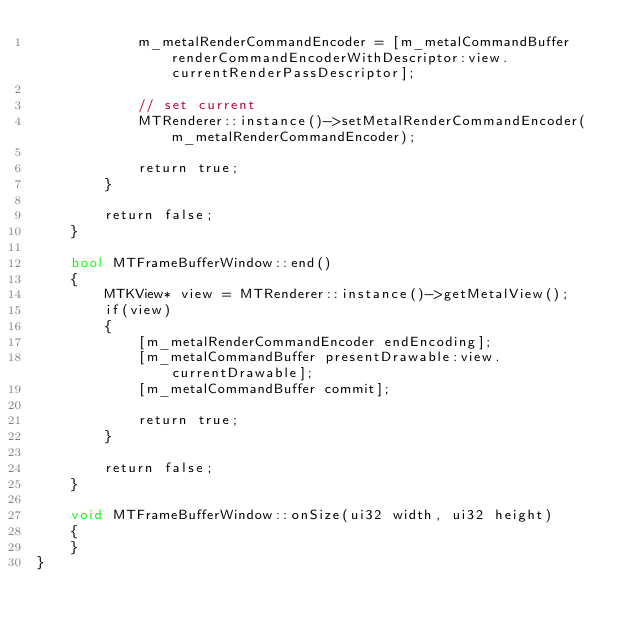<code> <loc_0><loc_0><loc_500><loc_500><_ObjectiveC_>            m_metalRenderCommandEncoder = [m_metalCommandBuffer renderCommandEncoderWithDescriptor:view.currentRenderPassDescriptor];
            
            // set current
            MTRenderer::instance()->setMetalRenderCommandEncoder(m_metalRenderCommandEncoder);
            
            return true;
        }
        
        return false;
    }
    
    bool MTFrameBufferWindow::end()
    {
        MTKView* view = MTRenderer::instance()->getMetalView();
        if(view)
        {
            [m_metalRenderCommandEncoder endEncoding];
            [m_metalCommandBuffer presentDrawable:view.currentDrawable];
            [m_metalCommandBuffer commit];
            
            return true;
        }
        
        return false;
    }
    
    void MTFrameBufferWindow::onSize(ui32 width, ui32 height)
    {
    }
}
</code> 